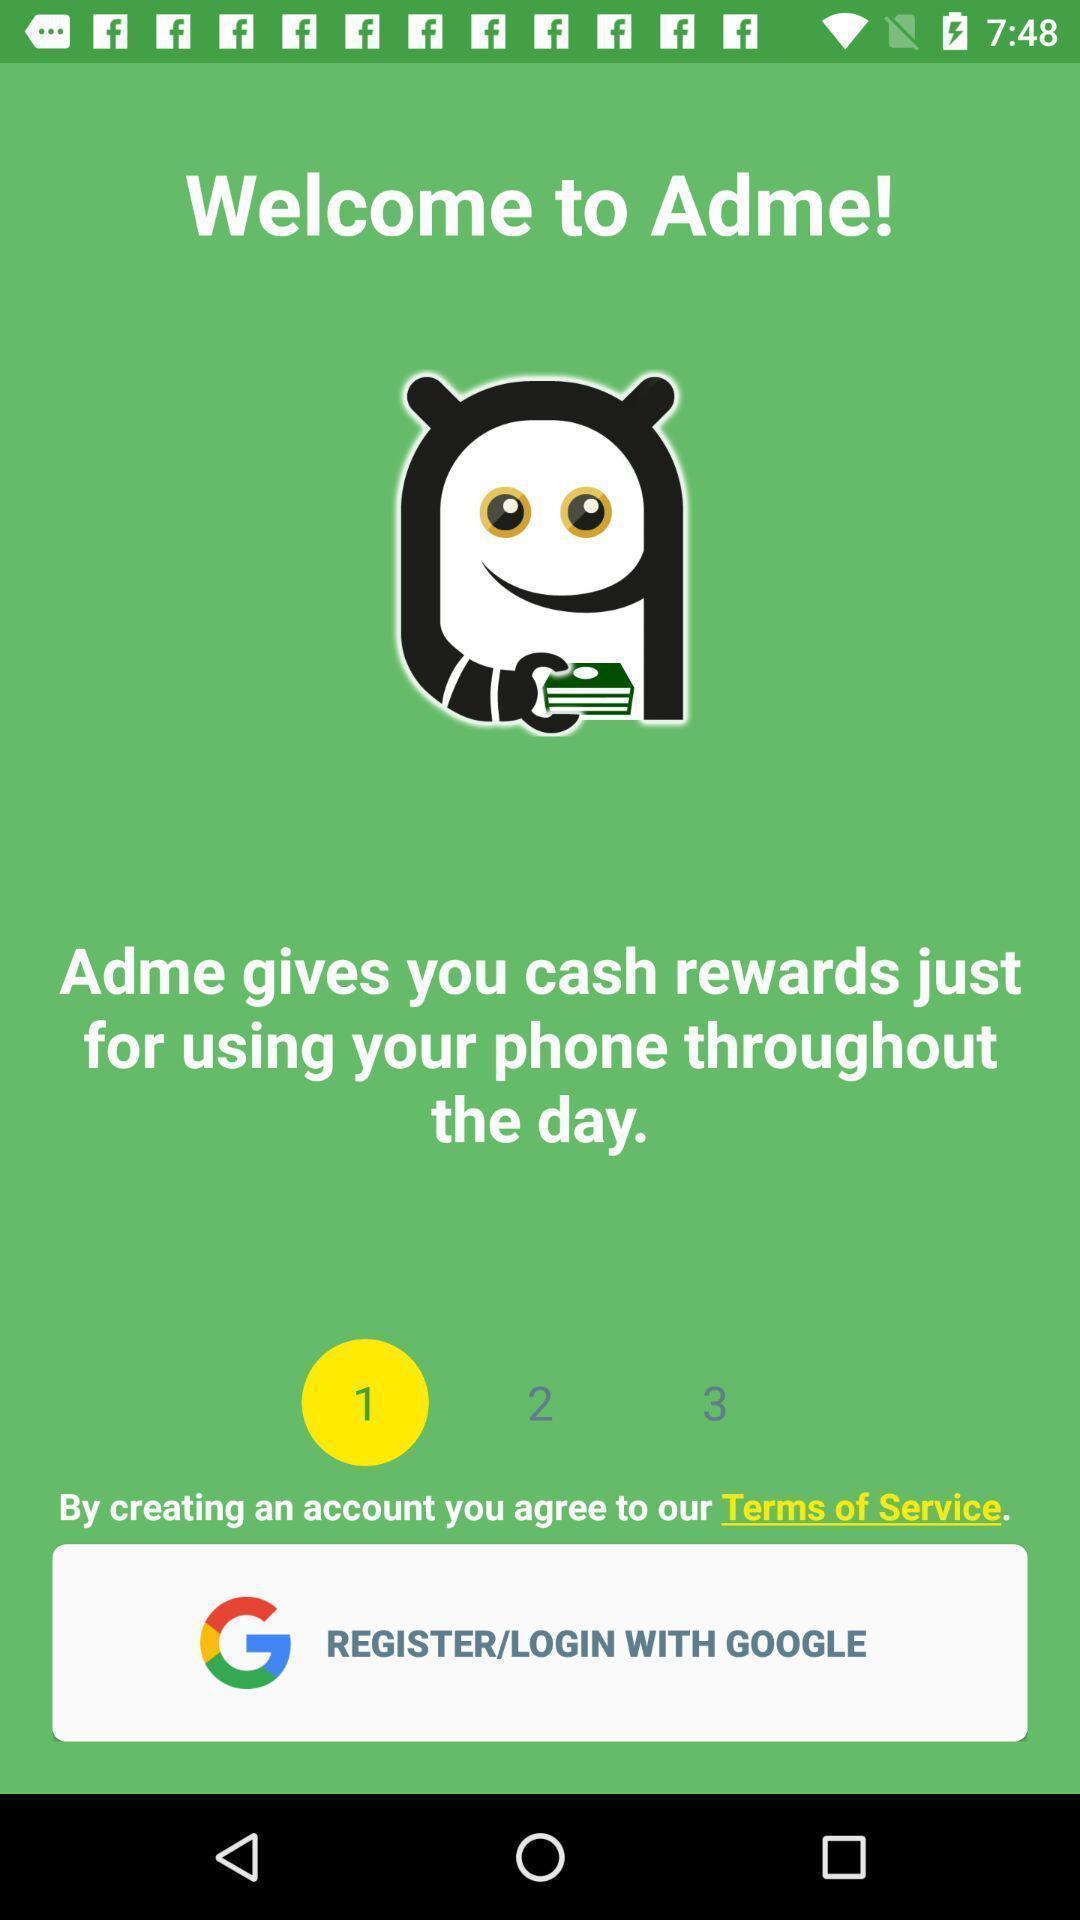Give me a narrative description of this picture. Welcome page of the cash rewarding app. 